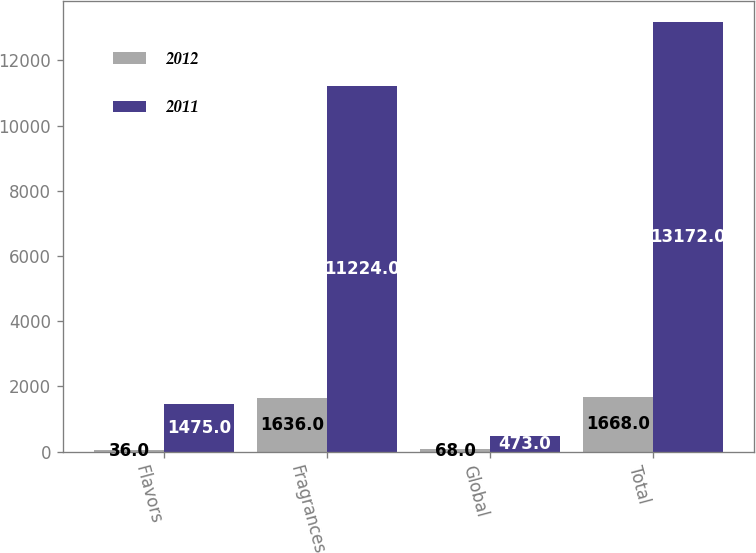<chart> <loc_0><loc_0><loc_500><loc_500><stacked_bar_chart><ecel><fcel>Flavors<fcel>Fragrances<fcel>Global<fcel>Total<nl><fcel>2012<fcel>36<fcel>1636<fcel>68<fcel>1668<nl><fcel>2011<fcel>1475<fcel>11224<fcel>473<fcel>13172<nl></chart> 